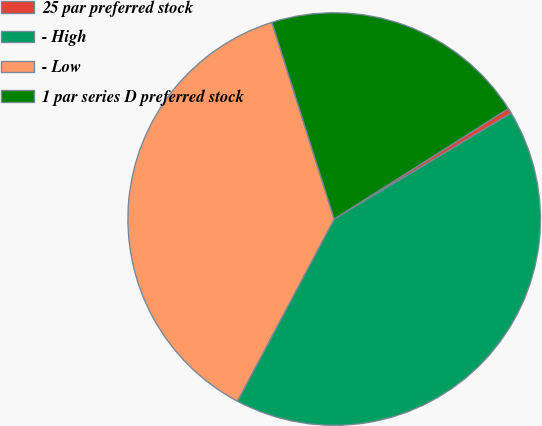<chart> <loc_0><loc_0><loc_500><loc_500><pie_chart><fcel>25 par preferred stock<fcel>- High<fcel>- Low<fcel>1 par series D preferred stock<nl><fcel>0.41%<fcel>41.35%<fcel>37.35%<fcel>20.89%<nl></chart> 